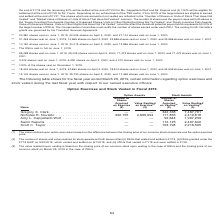According to Nortonlifelock's financial document, What does the table show? for the fiscal year ended March 29, 2019, certain information regarding option exercises and stock vested during the last fiscal year with respect to our named executive officers. The document states: "The following table shows for the fiscal year ended March 29, 2019, certain information regarding option exercises and stock vested during the last fi..." Also, What is value realized upon option exercises is based on? the difference between the closing price of our common stock at exercise and the option exercise price.. The document states: "e value realized upon option exercises is based on the difference between the closing price of our common stock at exercise and the option exercise pr..." Also, What is the Value realized on vesting for stock awards for Scott C. Taylor? According to the financial document, 2,216,595. The relevant text states: "— 112,125 2,497,640 Scott C. Taylor . — — 103,798 2,216,595..." Also, can you calculate: What is the total value realized on vesting for stock awards for all named executive officers? Based on the calculation:  7,467,791+2,419,818+1,997,239+2,497,640+2,216,595, the result is 16599083. This is based on the information: "Nicholas R. Noviello . 332,155 4,699,993 111,855 2,419,818 Amy L. Cappellanti-Wolf . — — 92,644 1,997,239 Samir Kapuria . — — 112,125 2,497,640 Scott C. Taylo — — 92,644 1,997,239 Samir Kapuria . — — ..." The key data points involved are: 1,997,239, 2,216,595, 2,419,818. Also, can you calculate: What is the average total value realized on vesting for all named executive officers? To answer this question, I need to perform calculations using the financial data. The calculation is: (7,467,791+2,419,818+1,997,239+2,497,640+2,216,595)/5, which equals 3319816.6. This is based on the information: "Nicholas R. Noviello . 332,155 4,699,993 111,855 2,419,818 Amy L. Cappellanti-Wolf . — — 92,644 1,997,239 Samir Kapuria . — — 112,125 2,497,640 Scott C. Taylo — — 92,644 1,997,239 Samir Kapuria . — — ..." The key data points involved are: 1,997,239, 2,216,595, 2,419,818. Also, can you calculate: How much more shares acquired on vesting did Gregory S. Clark have over  Nicholas R. Noviello? Based on the calculation: 342,338-111,855, the result is 230483. This is based on the information: "Gregory S. Clark . — — 342,338 7,467,791 Nicholas R. Noviello . 332,155 4,699,993 111,855 2,419,818 Amy L. Cappellanti-Wolf . — — ,467,791 Nicholas R. Noviello . 332,155 4,699,993 111,855 2,419,818 Am..." The key data points involved are: 111,855, 342,338. 